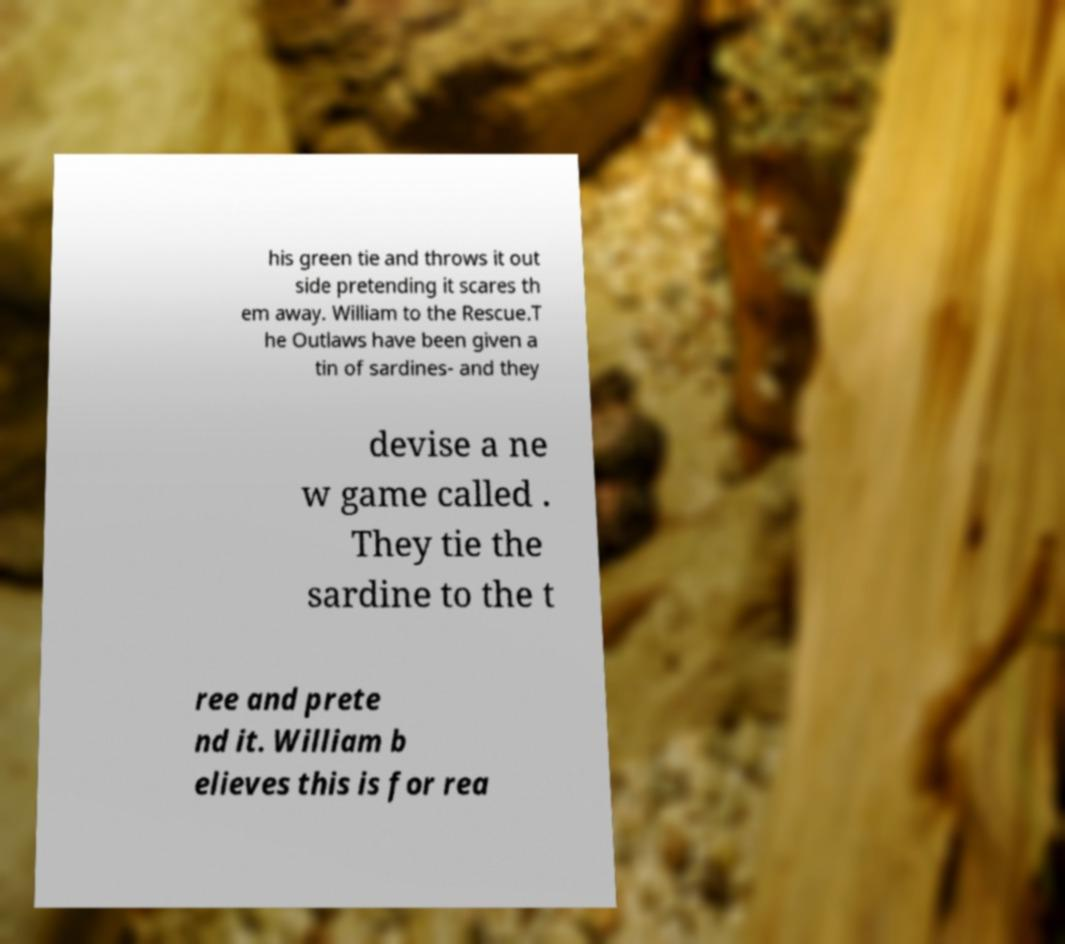Please read and relay the text visible in this image. What does it say? his green tie and throws it out side pretending it scares th em away. William to the Rescue.T he Outlaws have been given a tin of sardines- and they devise a ne w game called . They tie the sardine to the t ree and prete nd it. William b elieves this is for rea 